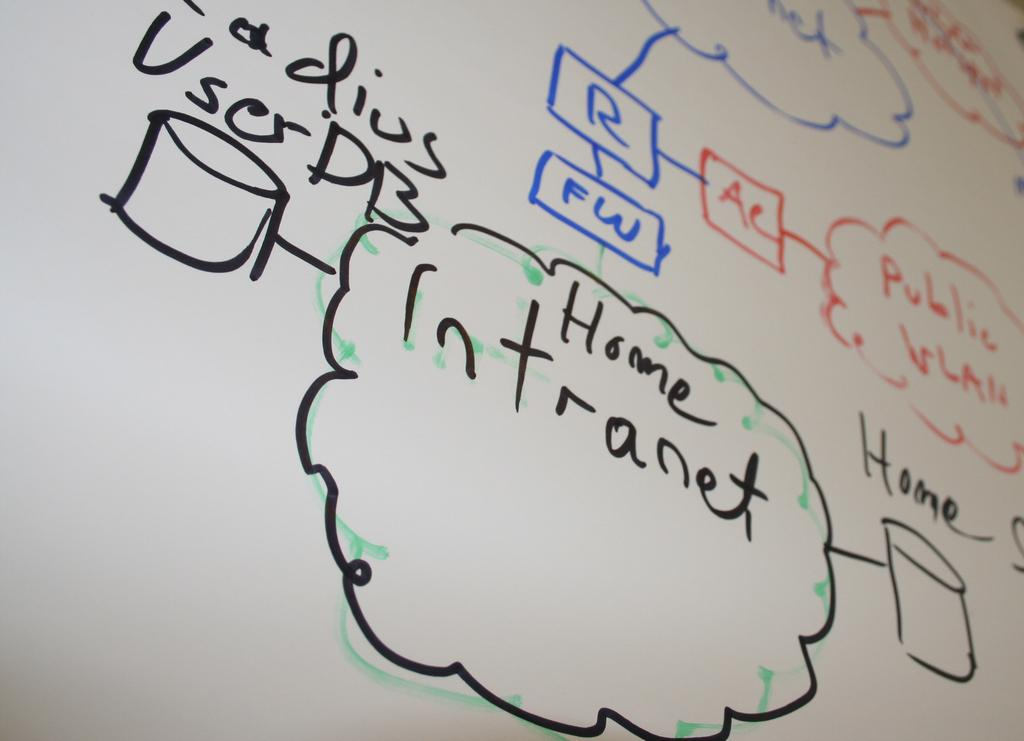<image>
Write a terse but informative summary of the picture. White board which has a bubble that says "Home Intranet". 